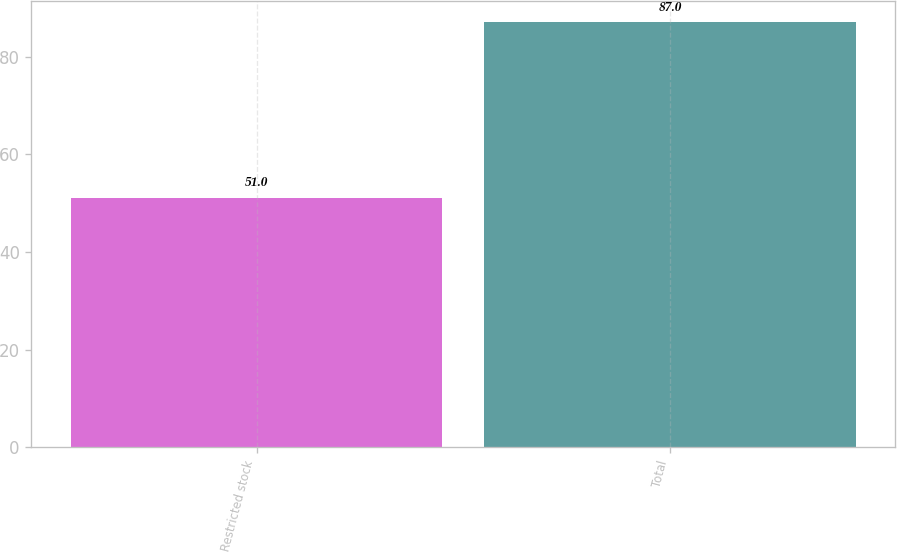<chart> <loc_0><loc_0><loc_500><loc_500><bar_chart><fcel>Restricted stock<fcel>Total<nl><fcel>51<fcel>87<nl></chart> 